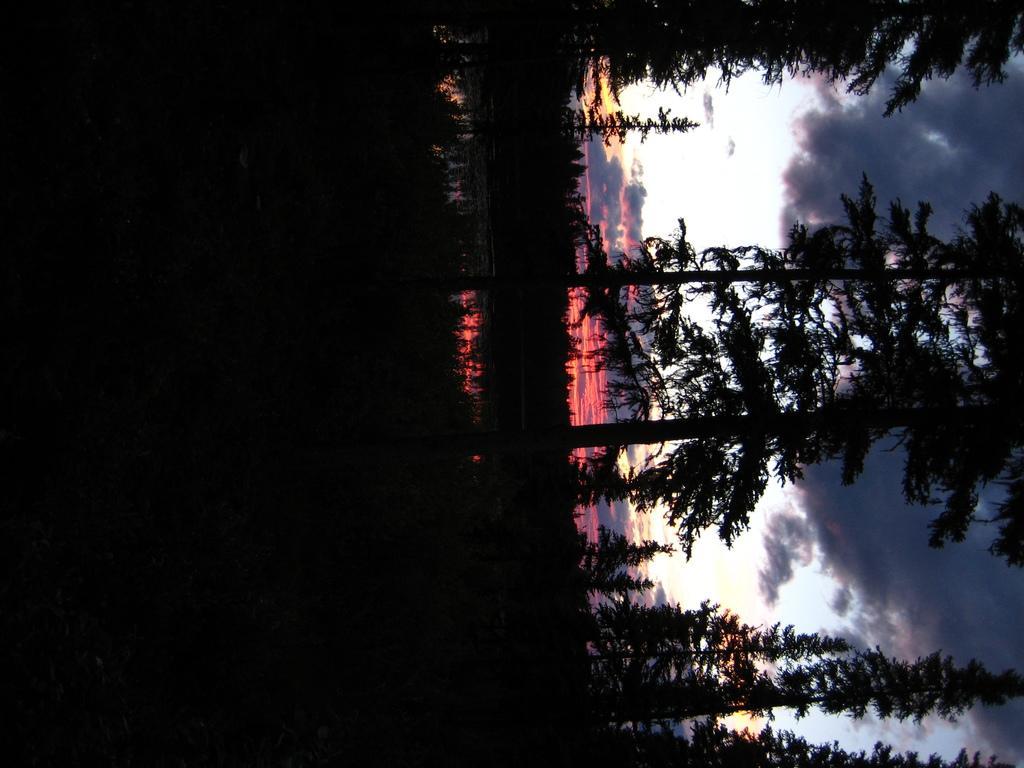Describe this image in one or two sentences. This is an inverted image. On the right we can see there are many trees. The sky is cloudy. 